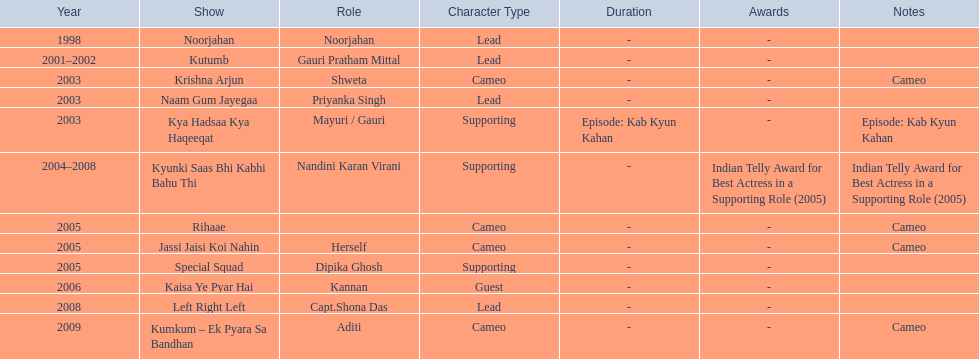What shows has gauri pradhan tejwani been in? Noorjahan, Kutumb, Krishna Arjun, Naam Gum Jayegaa, Kya Hadsaa Kya Haqeeqat, Kyunki Saas Bhi Kabhi Bahu Thi, Rihaae, Jassi Jaisi Koi Nahin, Special Squad, Kaisa Ye Pyar Hai, Left Right Left, Kumkum – Ek Pyara Sa Bandhan. Of these shows, which one lasted for more than a year? Kutumb, Kyunki Saas Bhi Kabhi Bahu Thi. Which of these lasted the longest? Kyunki Saas Bhi Kabhi Bahu Thi. 